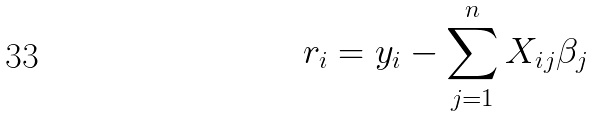Convert formula to latex. <formula><loc_0><loc_0><loc_500><loc_500>r _ { i } = y _ { i } - \sum _ { j = 1 } ^ { n } X _ { i j } \beta _ { j }</formula> 